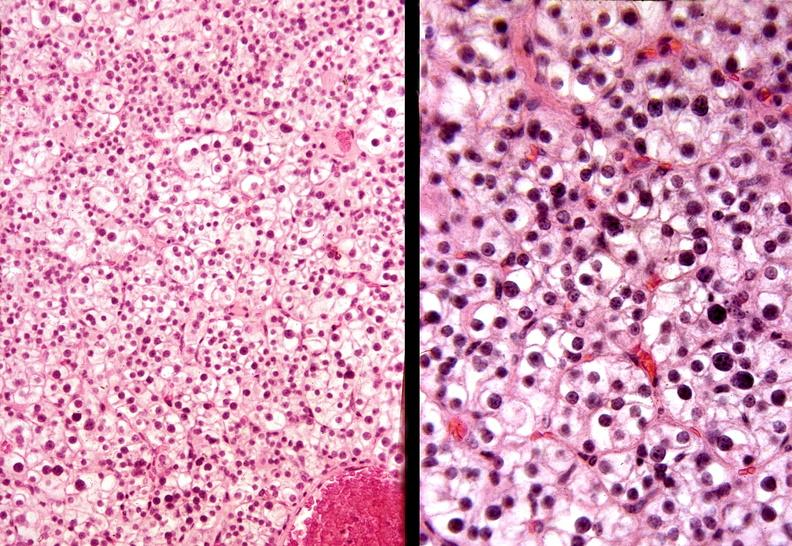does this image show parathyroid, adenoma, functional?
Answer the question using a single word or phrase. Yes 